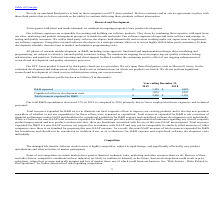Comparing values in Globalscape's report, By how much did the firm's R&D expenditures decrease by in 2019 as compared to 2018? According to the financial document, 23 (percentage). The relevant text states: "Our total R&D expenditures decreased 23% in 2019 as compared to 2018 primarily due to fewer employed software engineers and technical..." Also, What is the purpose of including "Total resources expended for R&D" in the table? Total resources expended for R&D serves to illustrate our total corporate efforts to improve our existing products and to develop new products regardless of whether or not our expenditures for those efforts were expensed or capitalized.. The document states: "Total resources expended for R&D serves to illustrate our total corporate efforts to improve our existing products and to develop new products regardl..." Also, can you calculate: By how much did the firm's capitalized software development costs decrease by in 2019 as compared to 2018? To answer this question, I need to perform calculations using the financial data. The calculation is: (1,276-1,074)/1,276, which equals 15.83 (percentage). This is based on the information: "Capitalized software development costs 1,074 1,276 Capitalized software development costs 1,074 1,276..." The key data points involved are: 1,074, 1,276. Also, What is the limitation of using total resources expensed for R&D? Total resources expended for R&D is a non-GAAP measure not prepared in accordance with GAAP and may not be comparable to similarly titled measures of other companies since there is no standard for preparing this non-GAAP measure.. The document states: "ociated with the use of this non-GAAP measurement. Total resources expended for R&D is a non-GAAP measure not prepared in accordance with GAAP and may..." Also, can you calculate: What is the difference between the R&D expensed in 2019 and 2018? Based on the calculation:  $1,355-$1,883 , the result is -528 (in thousands). This is based on the information: "R&D expensed $ 1,355 $ 1,883 R&D expensed $ 1,355 $ 1,883..." The key data points involved are: 1,355, 1,883. Also, can you calculate: What is the difference between the total resources expensed for R&D in 2019 and 2018? Based on the calculation: $2,430-$3,159, the result is -729 (in thousands). This is based on the information: "Total resources expensed for R&D $ 2,430 $ 3,159 Total resources expensed for R&D $ 2,430 $ 3,159..." The key data points involved are: 2,430, 3,159. 